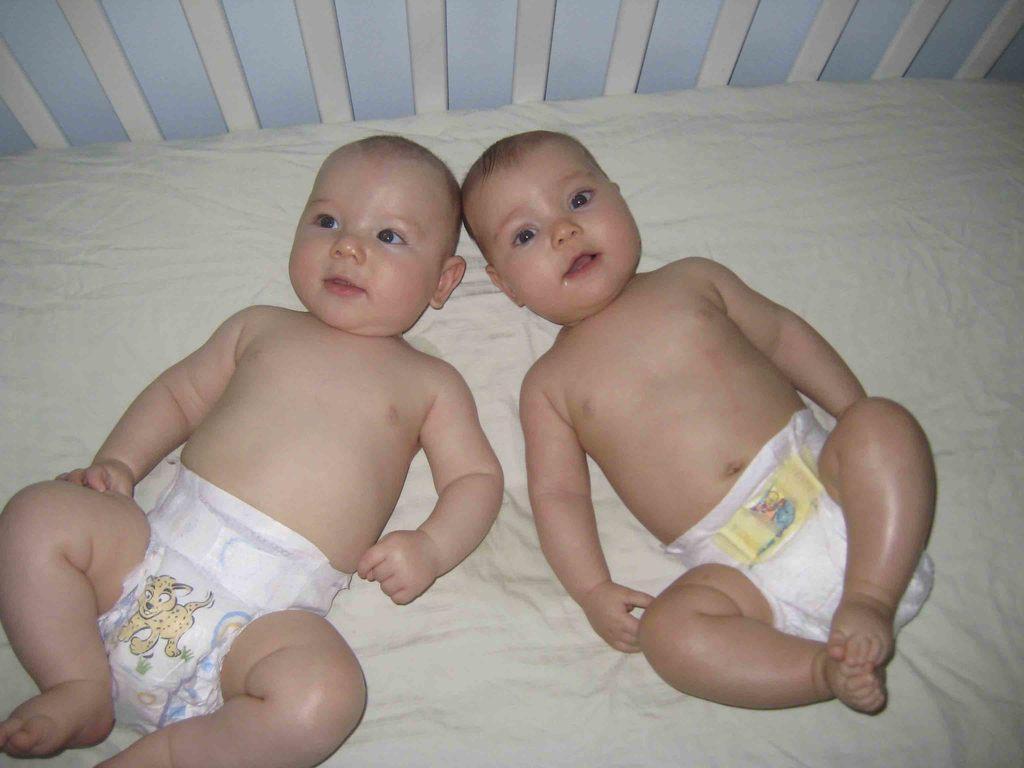Describe this image in one or two sentences. In this picture we can see two children are lying, they wore pampers, we can see a cradle at the bottom. 